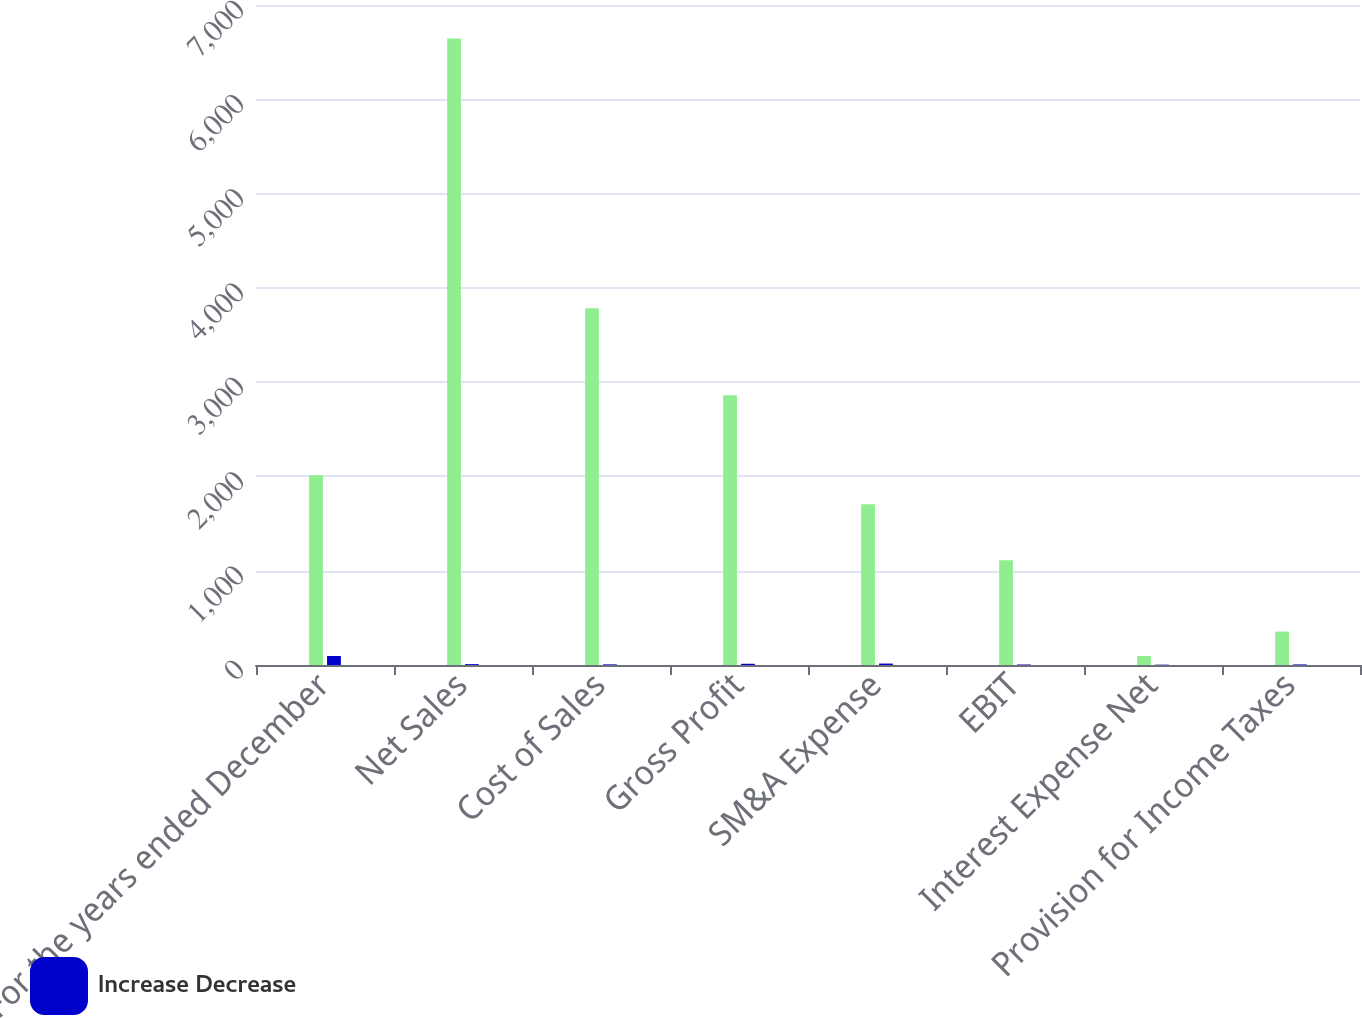Convert chart to OTSL. <chart><loc_0><loc_0><loc_500><loc_500><stacked_bar_chart><ecel><fcel>For the years ended December<fcel>Net Sales<fcel>Cost of Sales<fcel>Gross Profit<fcel>SM&A Expense<fcel>EBIT<fcel>Interest Expense Net<fcel>Provision for Income Taxes<nl><fcel>nan<fcel>2012<fcel>6644.3<fcel>3784.4<fcel>2859.9<fcel>1703.8<fcel>1111.1<fcel>95.6<fcel>354.6<nl><fcel>Increase Decrease<fcel>95.6<fcel>9.3<fcel>6.6<fcel>13<fcel>15.3<fcel>5.3<fcel>3.7<fcel>6.2<nl></chart> 